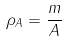Convert formula to latex. <formula><loc_0><loc_0><loc_500><loc_500>\rho _ { A } = \frac { m } { A }</formula> 